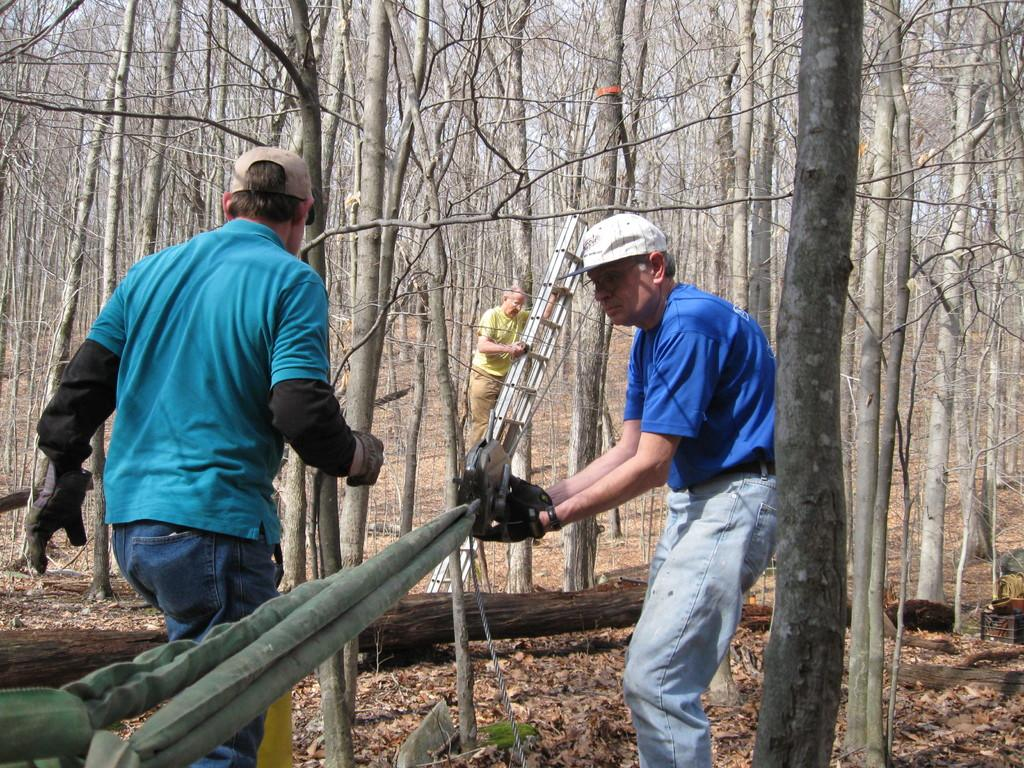How many people are in the image? There are people in the image, but the exact number is not specified. What is one person doing in the image? One person is holding an object in the image. What can be seen in the image that is used for climbing or lifting? There is a rope and a ladder in the image. What color are the objects in the image? There are green objects in the image. What type of vegetation is visible in the image? There are trees in the image. What type of patch is being sewn onto the person's clothing in the image? There is no patch or sewing activity present in the image. What type of yard is visible in the image? There is no yard visible in the image. 